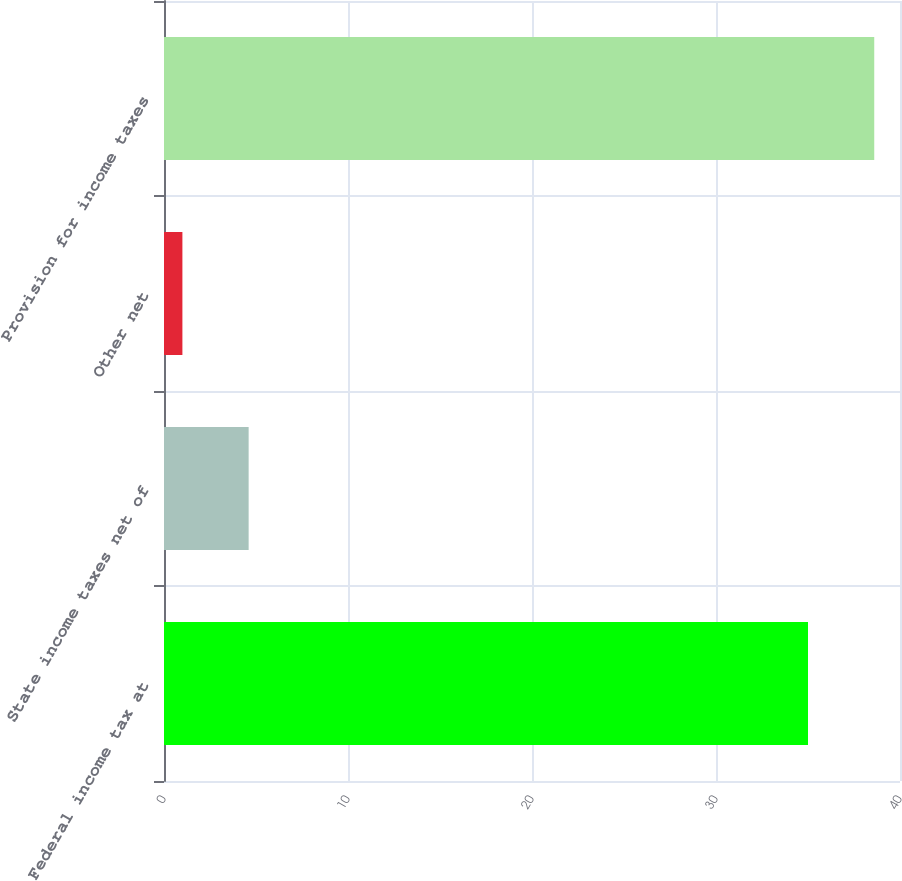Convert chart. <chart><loc_0><loc_0><loc_500><loc_500><bar_chart><fcel>Federal income tax at<fcel>State income taxes net of<fcel>Other net<fcel>Provision for income taxes<nl><fcel>35<fcel>4.6<fcel>1<fcel>38.6<nl></chart> 